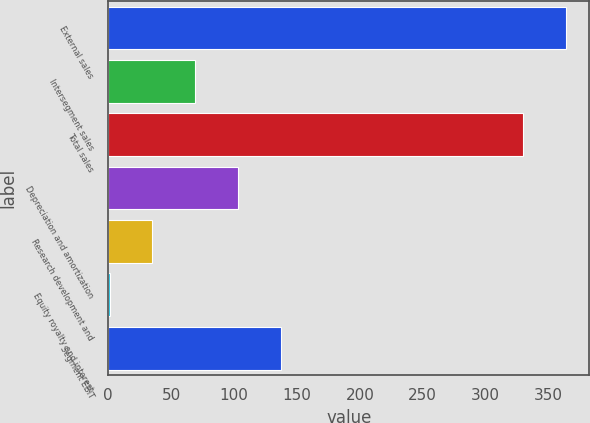Convert chart to OTSL. <chart><loc_0><loc_0><loc_500><loc_500><bar_chart><fcel>External sales<fcel>Intersegment sales<fcel>Total sales<fcel>Depreciation and amortization<fcel>Research development and<fcel>Equity royalty and interest<fcel>Segment EBIT<nl><fcel>364.1<fcel>69.2<fcel>330<fcel>103.3<fcel>35.1<fcel>1<fcel>137.4<nl></chart> 